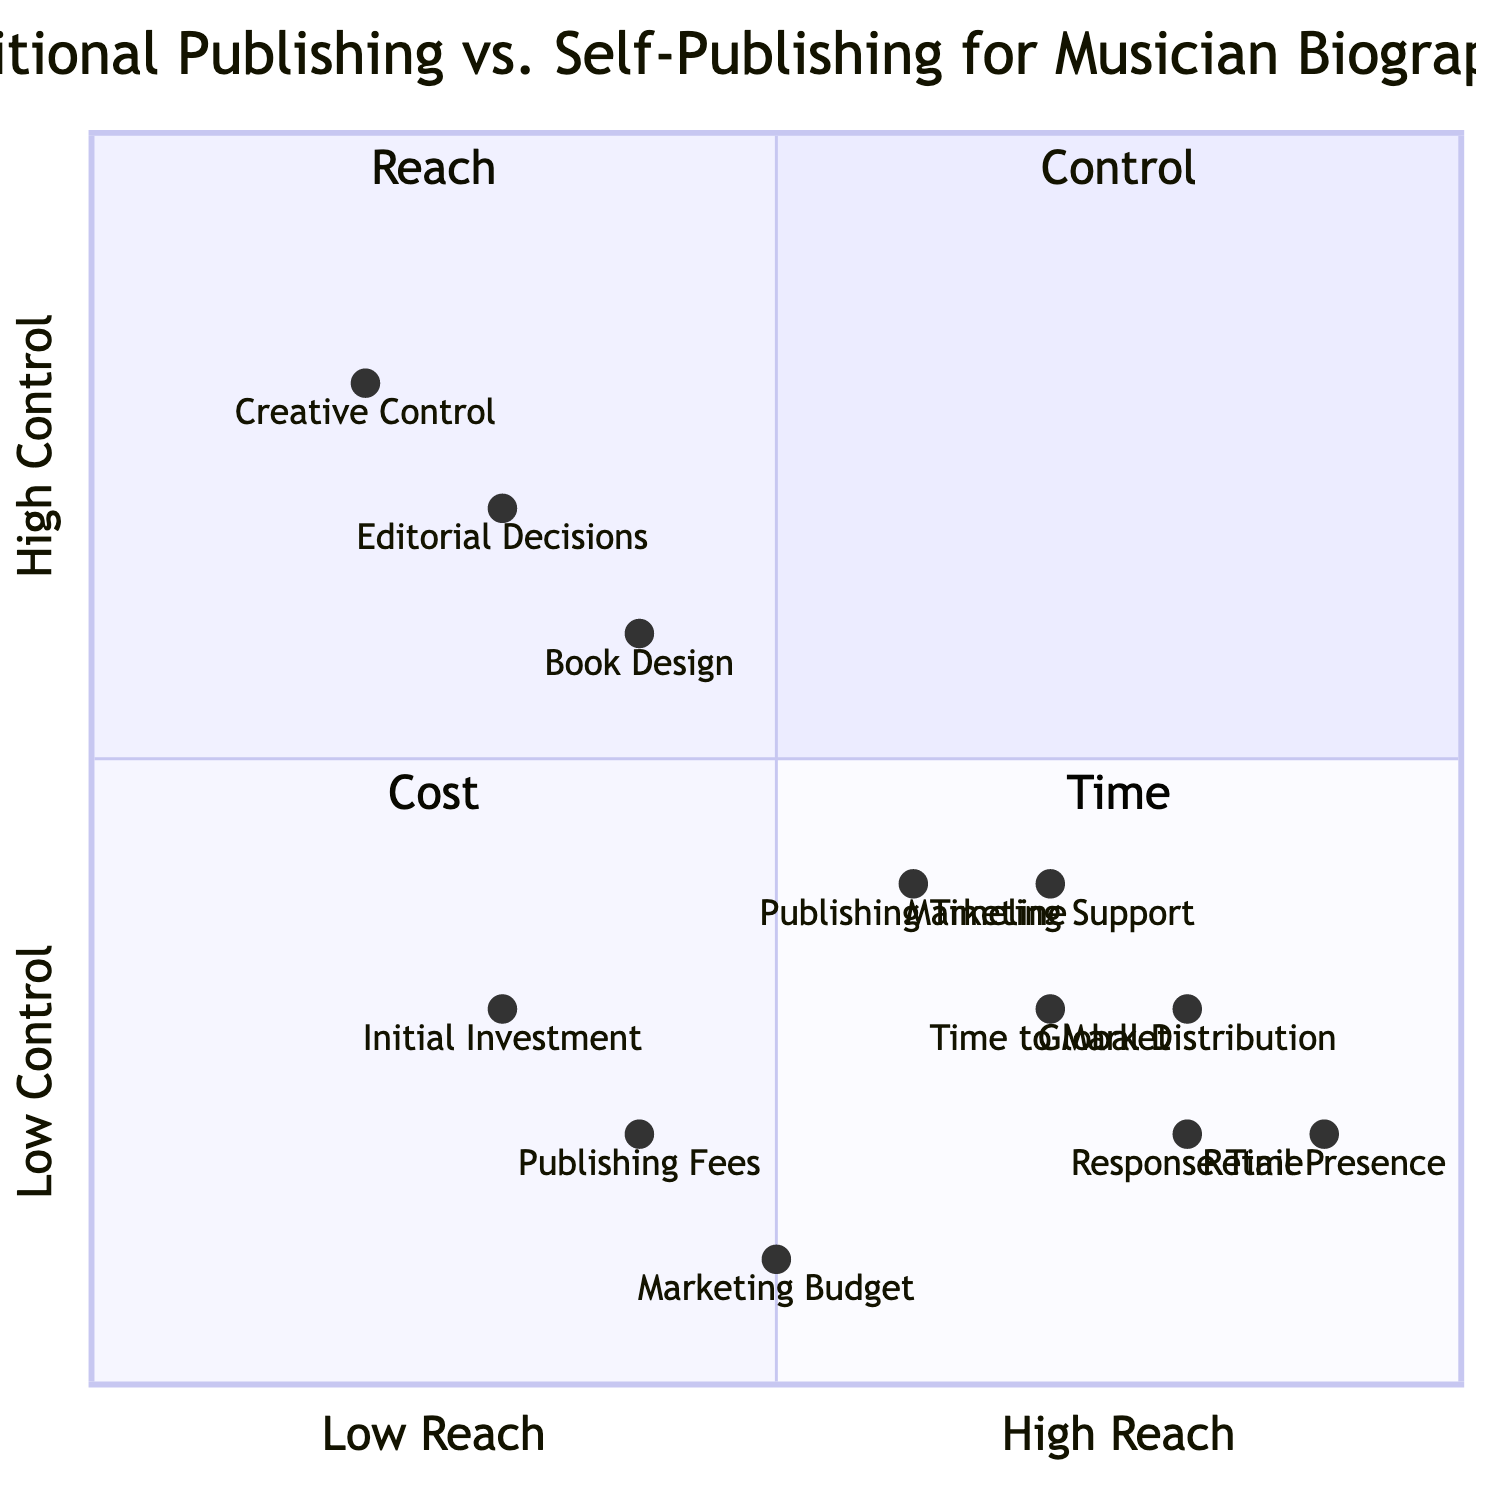What is the position of Creative Control in the quadrant chart? Creative Control is located at coordinates [0.2, 0.8] in the chart. The x-axis indicates low reach, and the y-axis indicates high control, placing Creative Control in the top-left quadrant, which represents high control.
Answer: [0.2, 0.8] Which element has the highest indication of Retail Presence? Retail Presence is positioned at [0.9, 0.2], which is further along the x-axis than the other elements in the Reach quadrant, indicating it has the highest value in that aspect of reach.
Answer: Retail Presence What is the relationship in focus between Initial Investment and Publishing Fees? Both Initial Investment and Publishing Fees are located in the bottom-left quadrant. Specifically, Initial Investment is at [0.3, 0.3] and Publishing Fees at [0.4, 0.2]. Since both metrics are associated with cost, they are compared with relatively low values indicating less financial burden.
Answer: Cost Which element ranks highest in the Reach quadrant? Among the elements in the Reach quadrant, Global Distribution is positioned at [0.8, 0.3], which is the highest value on the x-axis and indicates strong global reach compared to the others.
Answer: Global Distribution How would you describe the overall relationship between Time and Cost in musician biographies? Time is positioned in the bottom-right quadrant, whereas Cost is in the bottom-left quadrant, indicating that they are both in the lower sections of the chart but focused on different axes—Cost focused on financial concerns and Time on scheduling and delivery. They are inversely related as increasing costs could lead to quicker timelines.
Answer: Inversely related What is the y-axis value for Time to Market? The y-axis value for Time to Market is 0.3, indicating that it is closer to the low control end.
Answer: 0.3 Which quadrant represents the most control over the publishing process? The Control quadrant (top-left) represents the most control over the publishing process, focusing on elements like Creative Control, Editorial Decisions, and Book Design, all signs of high author influence.
Answer: Control What does a higher x-axis value indicate in the context of this diagram? A higher x-axis value indicates a greater level of reach in the traditional versus self-publishing comparison, meaning better distribution, marketing support, or retail presence.
Answer: Greater reach 